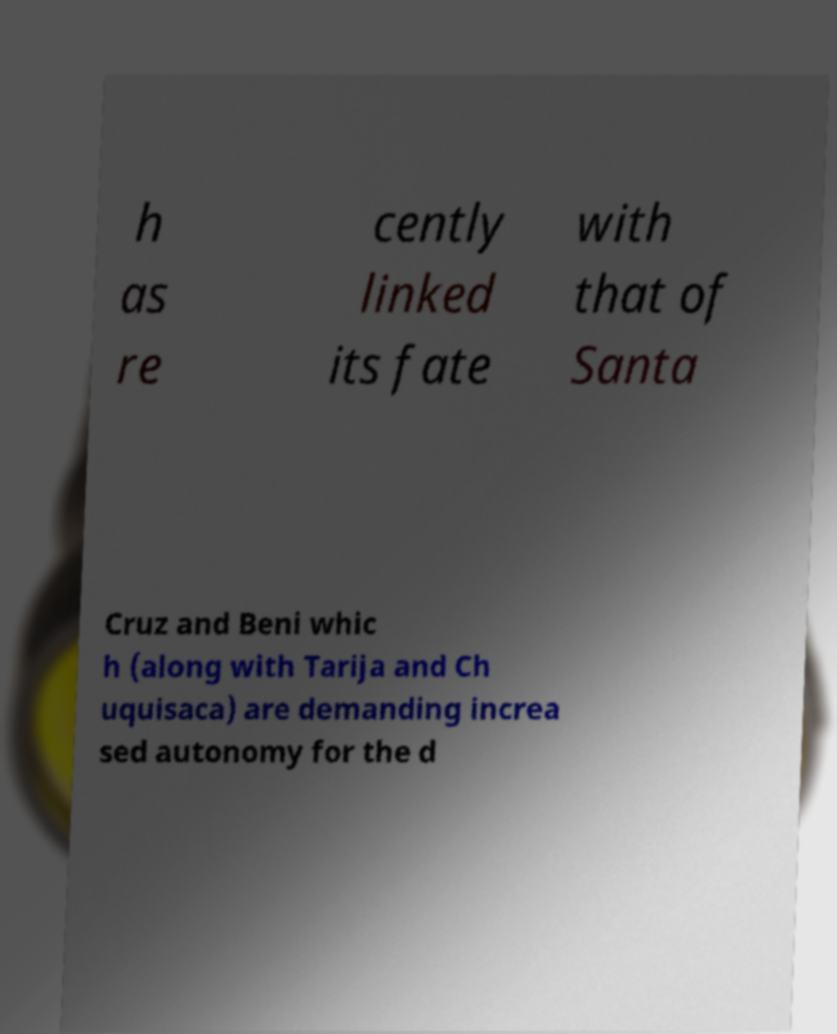Please read and relay the text visible in this image. What does it say? h as re cently linked its fate with that of Santa Cruz and Beni whic h (along with Tarija and Ch uquisaca) are demanding increa sed autonomy for the d 